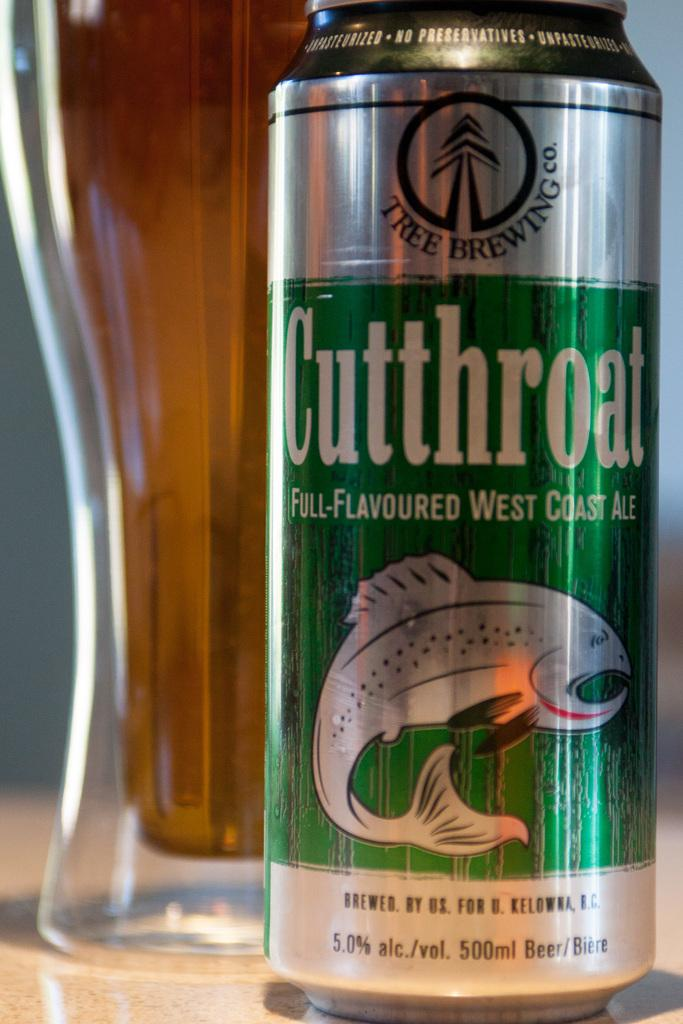What is the object with writing on it in the image? There is a can with writing on it in the image. What is featured on the can besides the writing? The can has a logo. What is the other object with a liquid in the image? There is a glass with a drink in the image. Where are these objects located in the image? All of these objects are on a surface. What type of ray can be seen swimming in the glass with a drink? There is no ray present in the image; it features a can and a glass with a drink on a surface. 